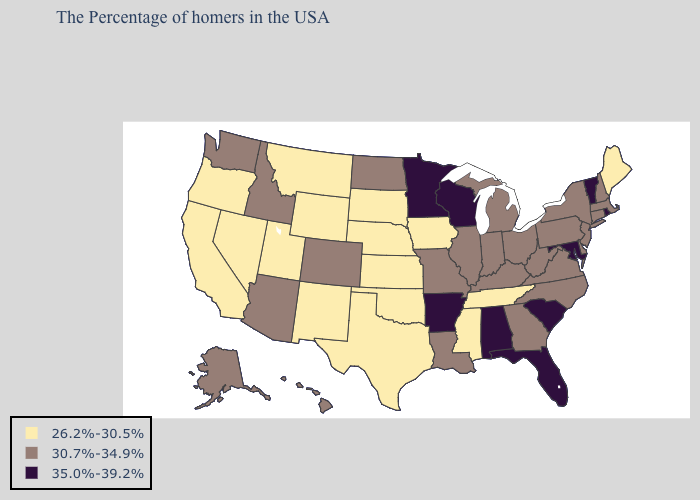Does Hawaii have a lower value than Kentucky?
Concise answer only. No. What is the highest value in the MidWest ?
Keep it brief. 35.0%-39.2%. What is the value of Arkansas?
Write a very short answer. 35.0%-39.2%. Name the states that have a value in the range 35.0%-39.2%?
Answer briefly. Rhode Island, Vermont, Maryland, South Carolina, Florida, Alabama, Wisconsin, Arkansas, Minnesota. Among the states that border North Dakota , which have the lowest value?
Be succinct. South Dakota, Montana. Name the states that have a value in the range 30.7%-34.9%?
Quick response, please. Massachusetts, New Hampshire, Connecticut, New York, New Jersey, Delaware, Pennsylvania, Virginia, North Carolina, West Virginia, Ohio, Georgia, Michigan, Kentucky, Indiana, Illinois, Louisiana, Missouri, North Dakota, Colorado, Arizona, Idaho, Washington, Alaska, Hawaii. Among the states that border Tennessee , does North Carolina have the lowest value?
Answer briefly. No. Does Illinois have a higher value than South Dakota?
Be succinct. Yes. Name the states that have a value in the range 26.2%-30.5%?
Short answer required. Maine, Tennessee, Mississippi, Iowa, Kansas, Nebraska, Oklahoma, Texas, South Dakota, Wyoming, New Mexico, Utah, Montana, Nevada, California, Oregon. Name the states that have a value in the range 30.7%-34.9%?
Answer briefly. Massachusetts, New Hampshire, Connecticut, New York, New Jersey, Delaware, Pennsylvania, Virginia, North Carolina, West Virginia, Ohio, Georgia, Michigan, Kentucky, Indiana, Illinois, Louisiana, Missouri, North Dakota, Colorado, Arizona, Idaho, Washington, Alaska, Hawaii. Name the states that have a value in the range 30.7%-34.9%?
Concise answer only. Massachusetts, New Hampshire, Connecticut, New York, New Jersey, Delaware, Pennsylvania, Virginia, North Carolina, West Virginia, Ohio, Georgia, Michigan, Kentucky, Indiana, Illinois, Louisiana, Missouri, North Dakota, Colorado, Arizona, Idaho, Washington, Alaska, Hawaii. Among the states that border Nevada , which have the lowest value?
Short answer required. Utah, California, Oregon. Does Massachusetts have the same value as Virginia?
Quick response, please. Yes. Name the states that have a value in the range 30.7%-34.9%?
Answer briefly. Massachusetts, New Hampshire, Connecticut, New York, New Jersey, Delaware, Pennsylvania, Virginia, North Carolina, West Virginia, Ohio, Georgia, Michigan, Kentucky, Indiana, Illinois, Louisiana, Missouri, North Dakota, Colorado, Arizona, Idaho, Washington, Alaska, Hawaii. Name the states that have a value in the range 26.2%-30.5%?
Quick response, please. Maine, Tennessee, Mississippi, Iowa, Kansas, Nebraska, Oklahoma, Texas, South Dakota, Wyoming, New Mexico, Utah, Montana, Nevada, California, Oregon. 